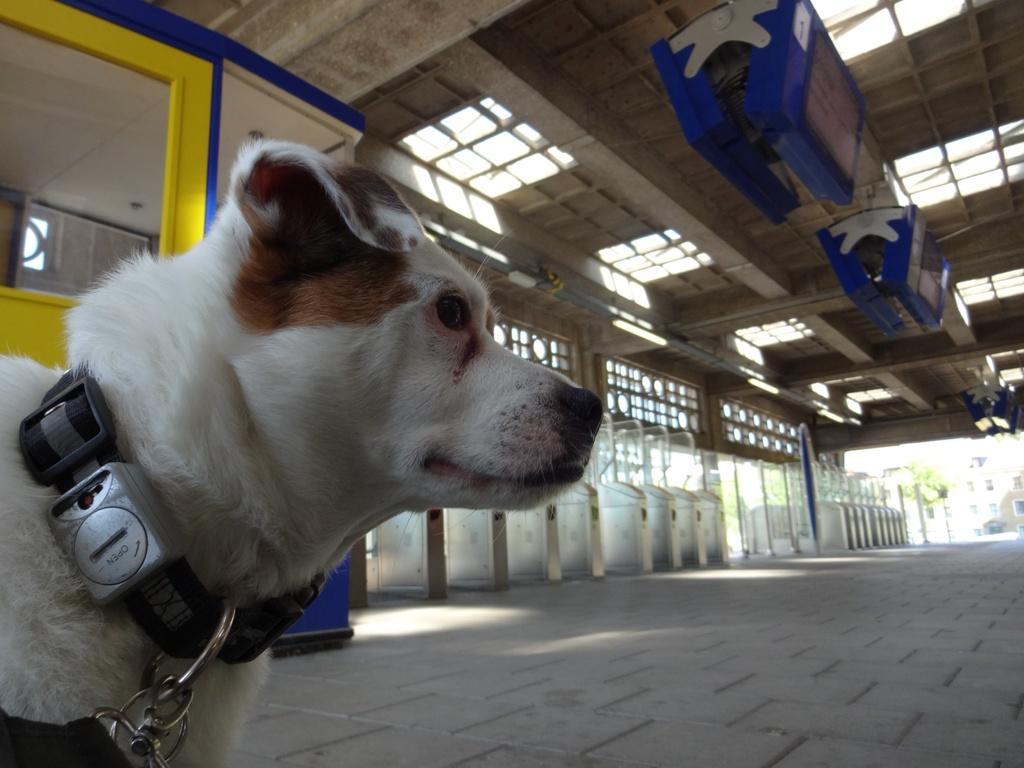In one or two sentences, can you explain what this image depicts? In this picture I can see there is a dog and it has a belt around its neck and there is a yellow color door and there are few blue objects attached to the ceiling and there are few buildings at right and trees. 